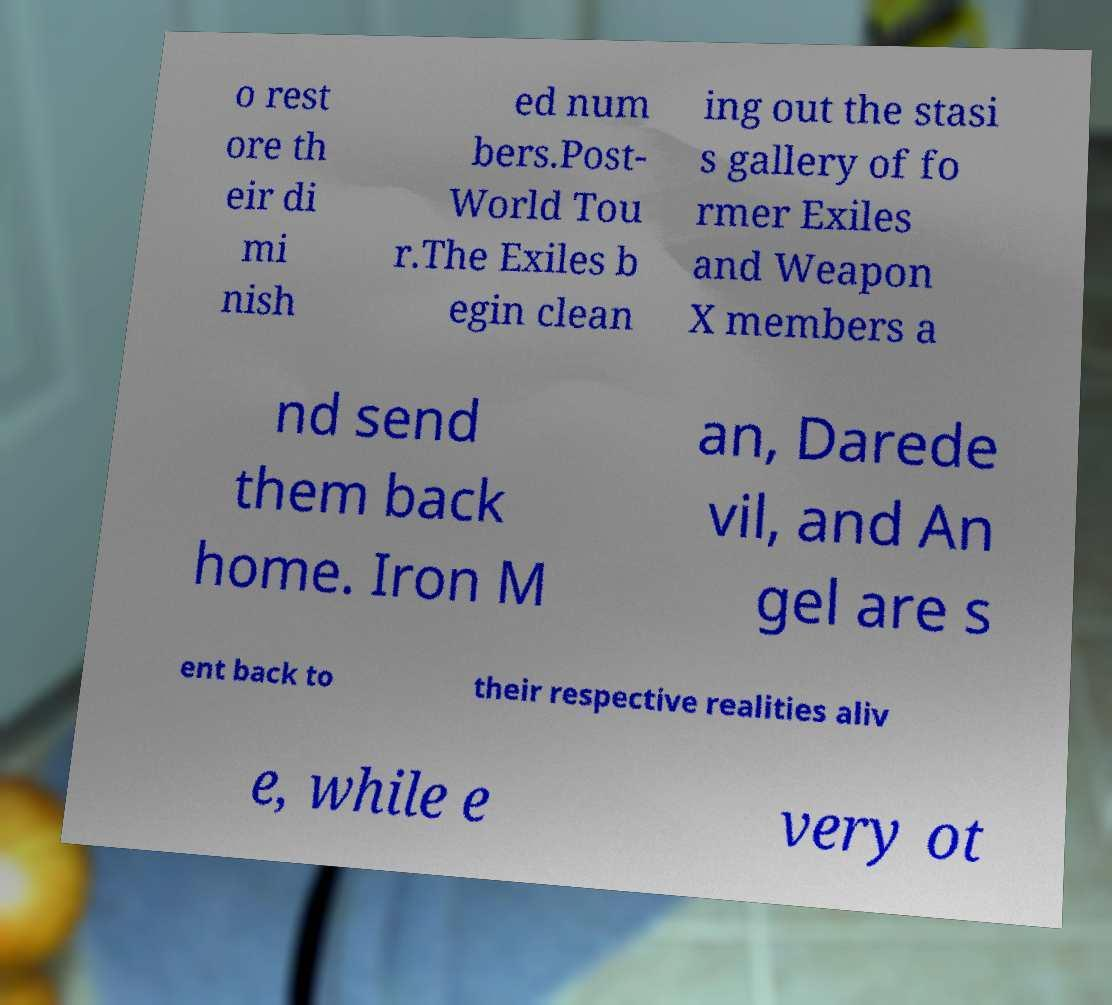I need the written content from this picture converted into text. Can you do that? o rest ore th eir di mi nish ed num bers.Post- World Tou r.The Exiles b egin clean ing out the stasi s gallery of fo rmer Exiles and Weapon X members a nd send them back home. Iron M an, Darede vil, and An gel are s ent back to their respective realities aliv e, while e very ot 